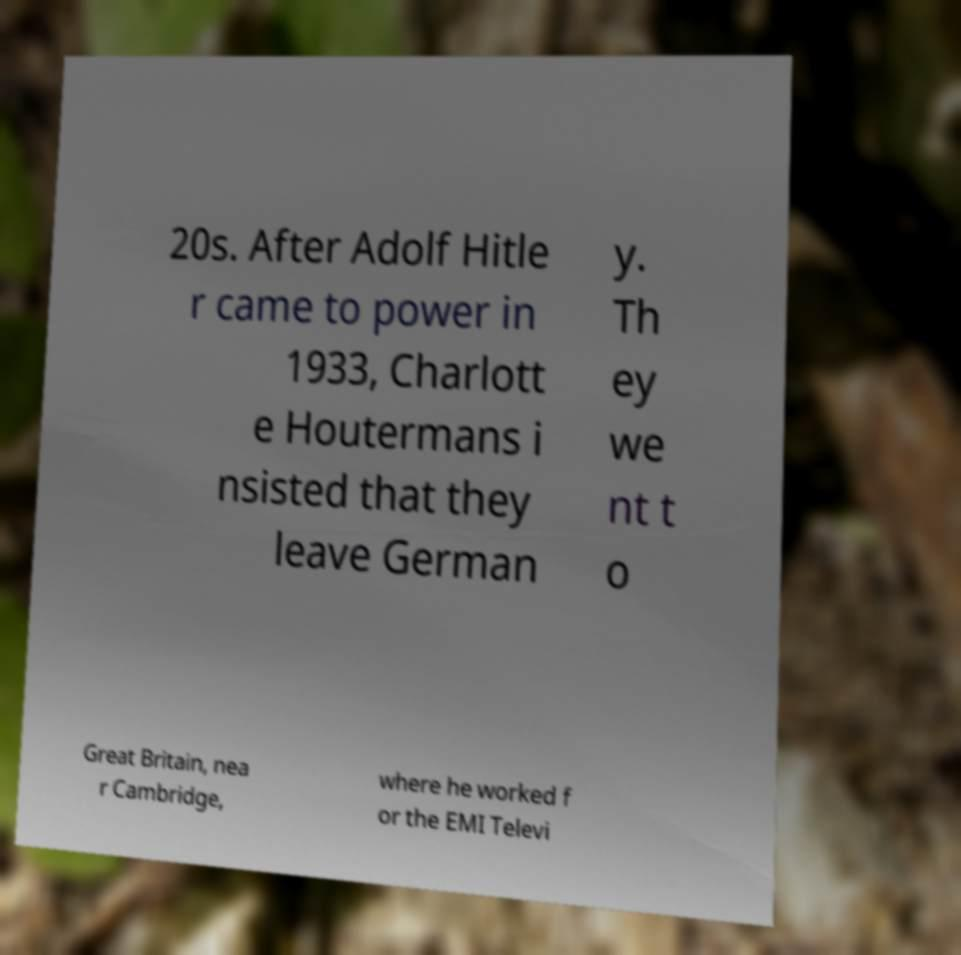Please identify and transcribe the text found in this image. 20s. After Adolf Hitle r came to power in 1933, Charlott e Houtermans i nsisted that they leave German y. Th ey we nt t o Great Britain, nea r Cambridge, where he worked f or the EMI Televi 